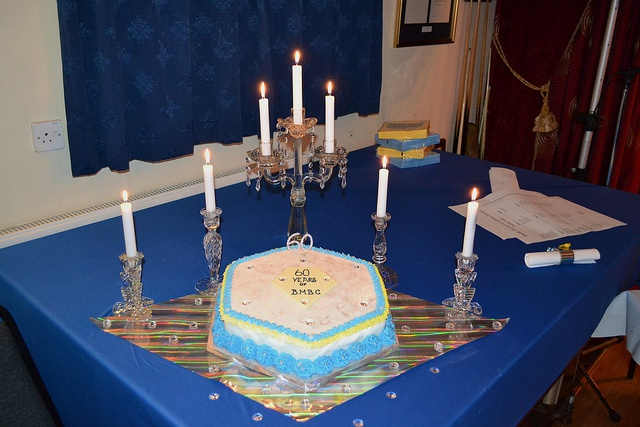Describe the objects in this image and their specific colors. I can see dining table in darkgray, navy, blue, black, and gray tones and cake in darkgray, tan, lightgray, and lightblue tones in this image. 